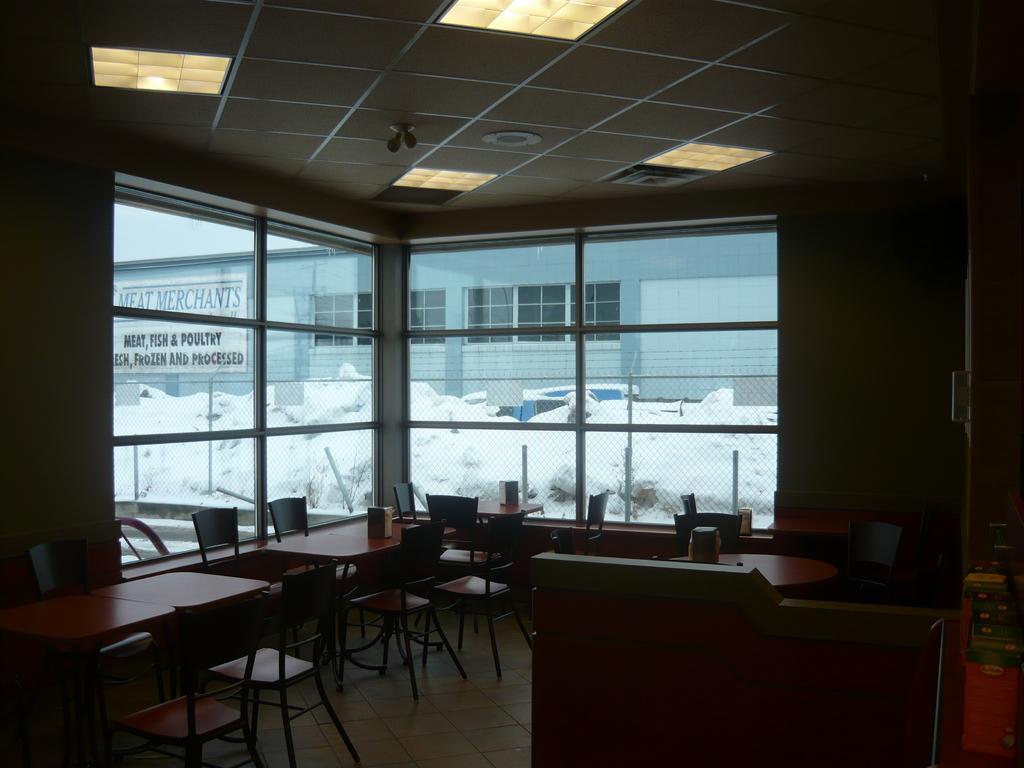In one or two sentences, can you explain what this image depicts? In this image there are empty chairs and tables, on the table there are objects. In the center there is a window and behind the window there are objects which are white in colour and there is a building and on the wall of the building there is some text written on it. 